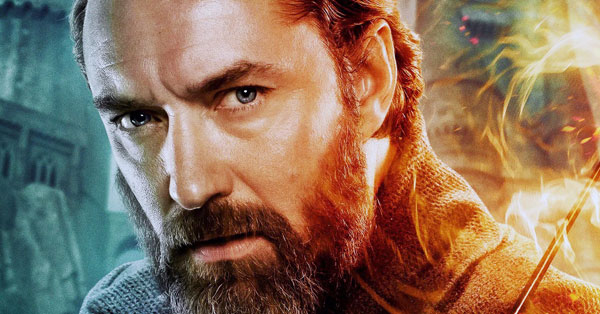Write a poem inspired by this image. In twilight’s whisper, shadows sway,
A sorcerer stands, his gaze astray,
With ancient wisdom in his eyes,
Beneath the cobalt, painted skies.

Flames dance around, with secrets told,
In silent sparks of orange and gold,
A castle looms in blurred retreat,
The echoes of time beneath his feet.

What worlds he’s seen, what battles fought,
In realms of magic, dreams are wrought,
An heir to legacies untold,
With every step, his power unfolds.

In this moment, fierce and still,
He bends the world unto his will,
For in his heart, the fires blaze,
A guardian in endless maze. 